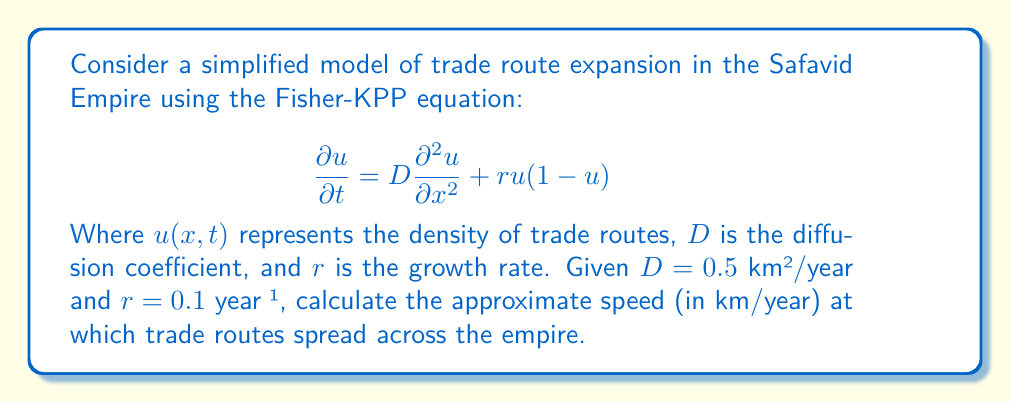Can you answer this question? To solve this problem, we'll use the formula for the asymptotic speed of propagation in the Fisher-KPP equation:

1) The formula for the speed of propagation is:

   $$c = 2\sqrt{Dr}$$

2) We're given:
   $D = 0.5$ km²/year
   $r = 0.1$ year⁻¹

3) Substituting these values into the formula:

   $$c = 2\sqrt{(0.5 \text{ km²/year})(0.1 \text{ year}^{-1})}$$

4) Simplify under the square root:

   $$c = 2\sqrt{0.05 \text{ km²/year²}}$$

5) Calculate the square root:

   $$c = 2(0.2236 \text{ km/year})$$

6) Multiply:

   $$c = 0.4472 \text{ km/year}$$

7) Round to two decimal places:

   $$c \approx 0.45 \text{ km/year}$$

This result suggests that trade routes in the Safavid Empire, according to this simplified model, spread at a speed of approximately 0.45 km per year.
Answer: 0.45 km/year 